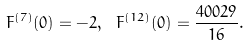Convert formula to latex. <formula><loc_0><loc_0><loc_500><loc_500>F ^ { ( 7 ) } ( 0 ) = - 2 , \ F ^ { ( 1 2 ) } ( 0 ) = \frac { 4 0 0 2 9 } { 1 6 } .</formula> 